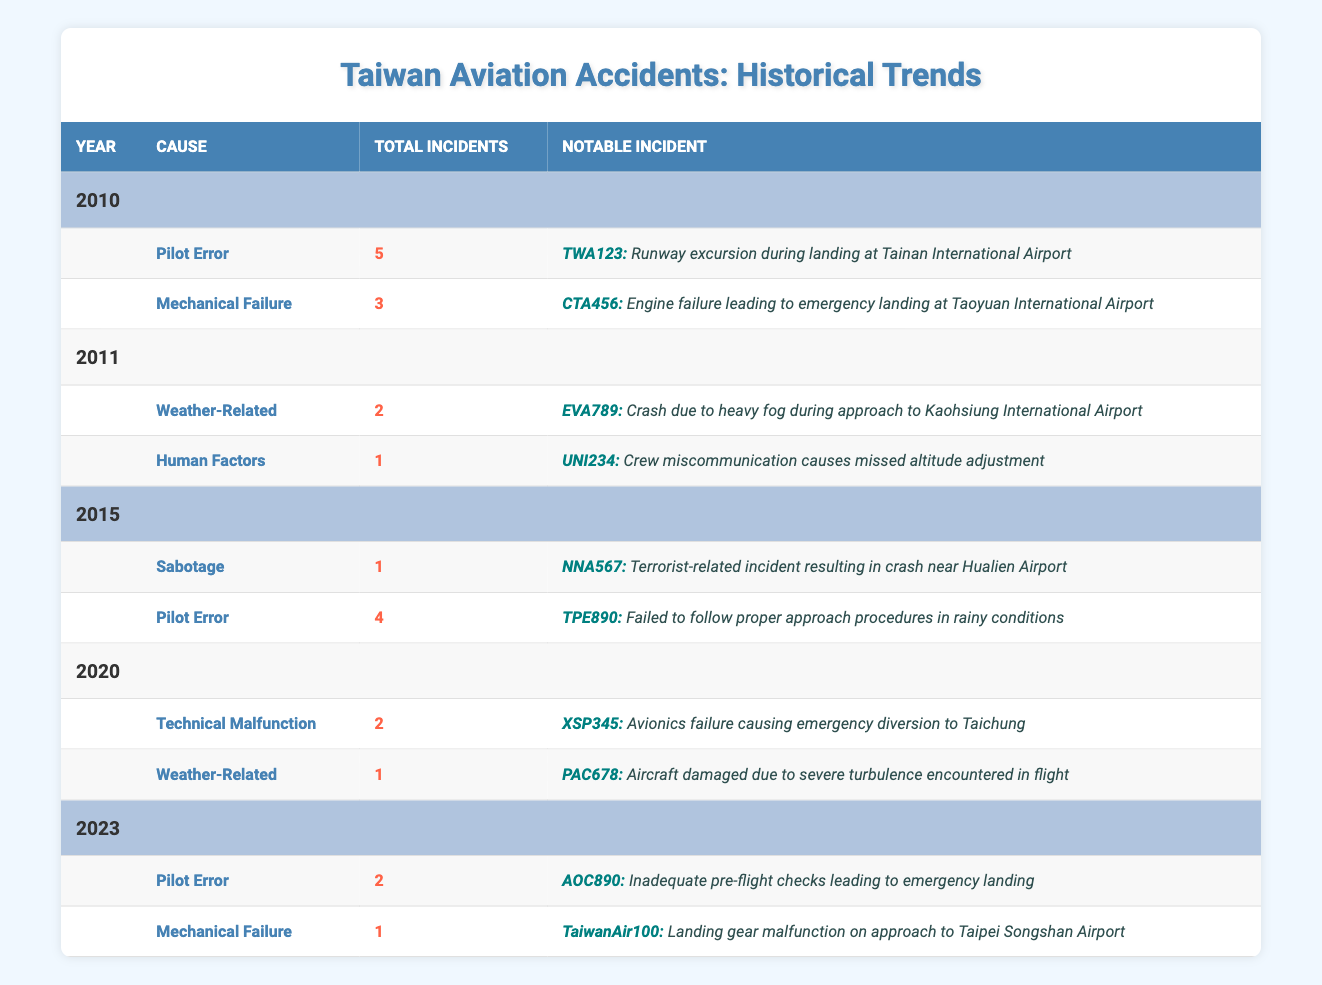What was the total number of aviation accidents in Taiwan in 2010? In the table, under the year 2010, we can find the total incidents listed for each cause. Summing the total incidents due to Pilot Error (5) and Mechanical Failure (3), we get 5 + 3 = 8 total accidents for the year 2010.
Answer: 8 Which year had the highest number of Pilot Error incidents? By reviewing the data under each year, we find that 2010 has 5 Pilot Error incidents, 2015 has 4, 2023 has 2, and there are no Pilot Error incidents in 2011 and 2020. Therefore, 2010 had the highest with 5 incidents.
Answer: 2010 Did any incidents related to Sabotage occur in 2020? Looking at the table, the year 2020 lists incidents under Technical Malfunction and Weather-Related causes, but there is no mention of Sabotage. Therefore, the answer is no, there were no Sabotage incidents in 2020.
Answer: No What is the total number of Mechanical Failure incidents recorded from 2010 to 2023? We find the total incidents of Mechanical Failure by checking each year: 2010 has 3, 2011 has none, 2015 has none, 2020 has none, and 2023 has 1. Adding these gives 3 + 0 + 0 + 0 + 1 = 4 incidents of Mechanical Failure over the years 2010 to 2023.
Answer: 4 Was there a year without any Weather-Related incidents? If so, which year? Checking the table, 2010 (none), 2011 (2), 2015 (none), 2020 (1), and 2023 (none) show that there were no Weather-Related incidents in 2010, 2015, and 2023. The answer to the question is yes, there were years without Weather-Related incidents: 2010, 2015, and 2023.
Answer: Yes, 2010, 2015, and 2023 What percentage of total incidents in 2015 were due to Pilot Error? For 2015, there are a total of 5 incidents (1 Sabotage and 4 Pilot Error). To find the percentage of incidents caused by Pilot Error, we take (4 Pilot Error / 5 Total Incidents) * 100%, which is 80%. Thus, 80% of the incidents in 2015 were due to Pilot Error.
Answer: 80% 